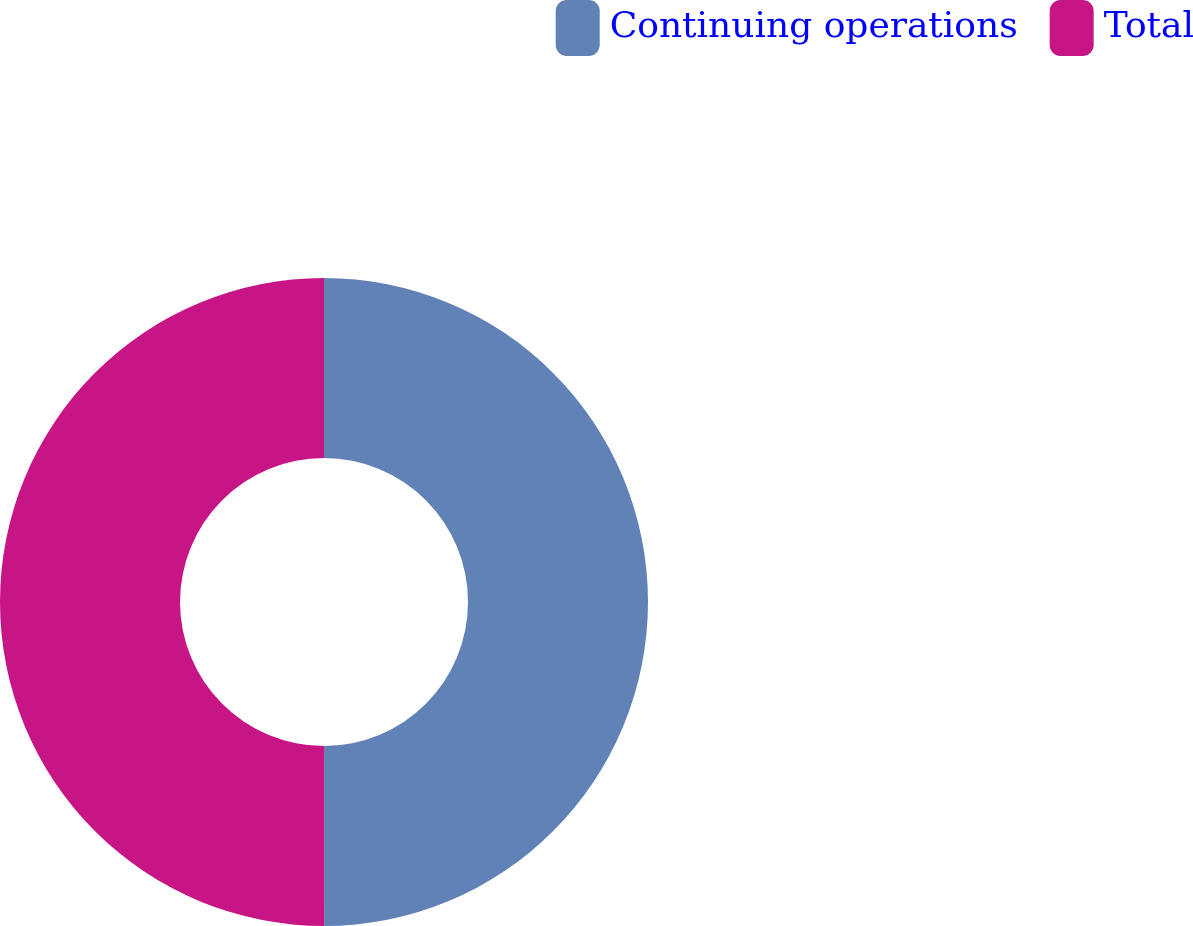Convert chart to OTSL. <chart><loc_0><loc_0><loc_500><loc_500><pie_chart><fcel>Continuing operations<fcel>Total<nl><fcel>49.99%<fcel>50.01%<nl></chart> 